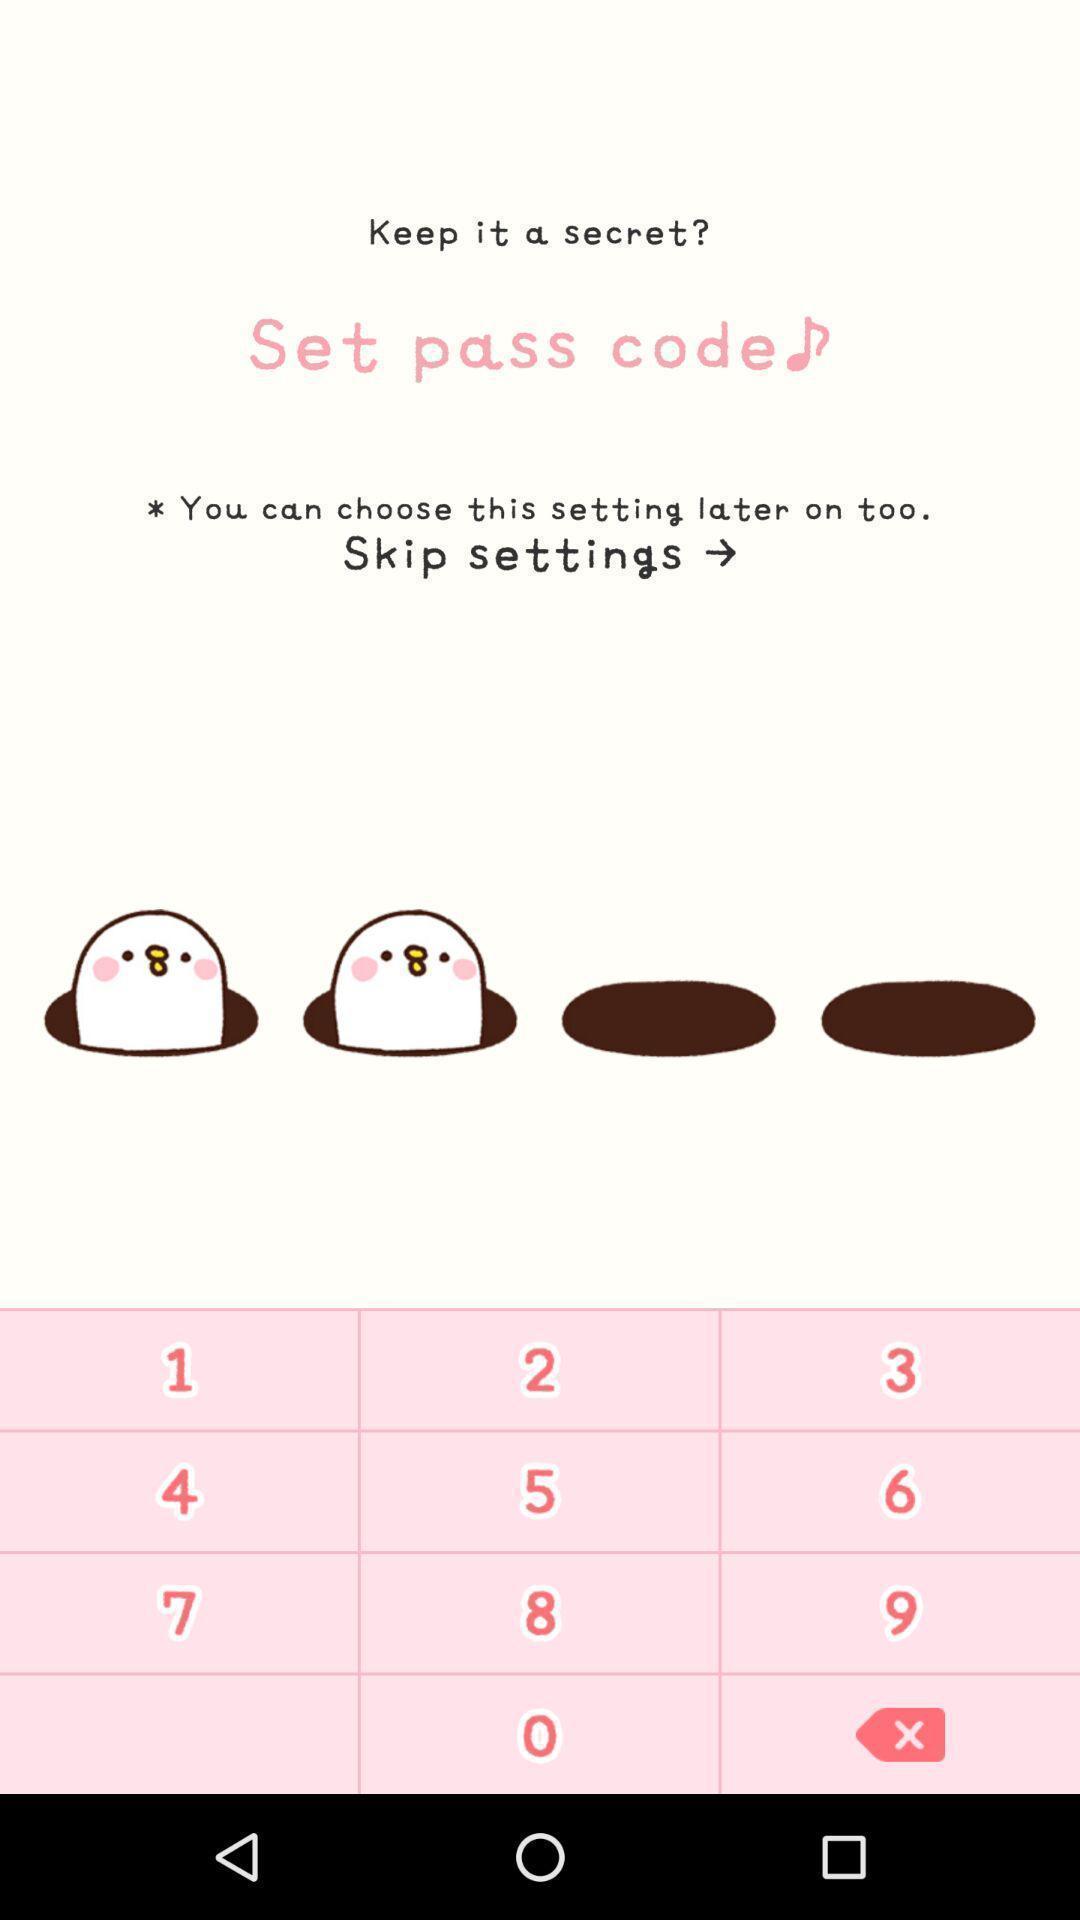Describe the visual elements of this screenshot. Page with keyboard for entering a passcode. 